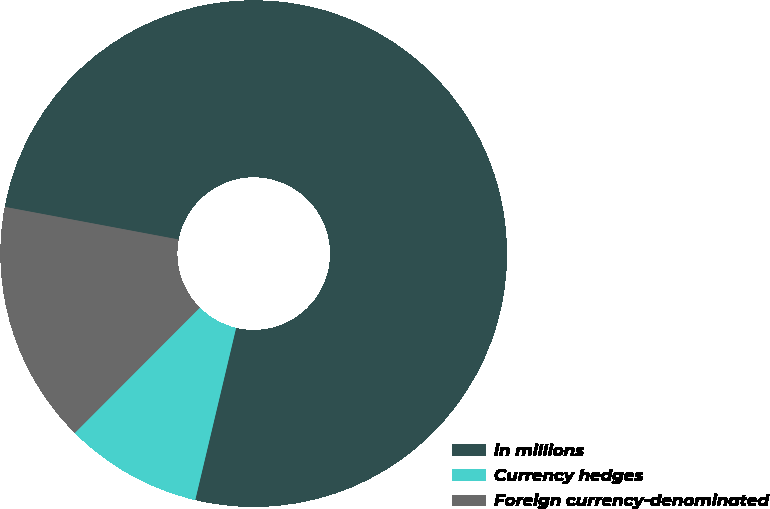Convert chart to OTSL. <chart><loc_0><loc_0><loc_500><loc_500><pie_chart><fcel>in millions<fcel>Currency hedges<fcel>Foreign currency-denominated<nl><fcel>75.76%<fcel>8.77%<fcel>15.47%<nl></chart> 